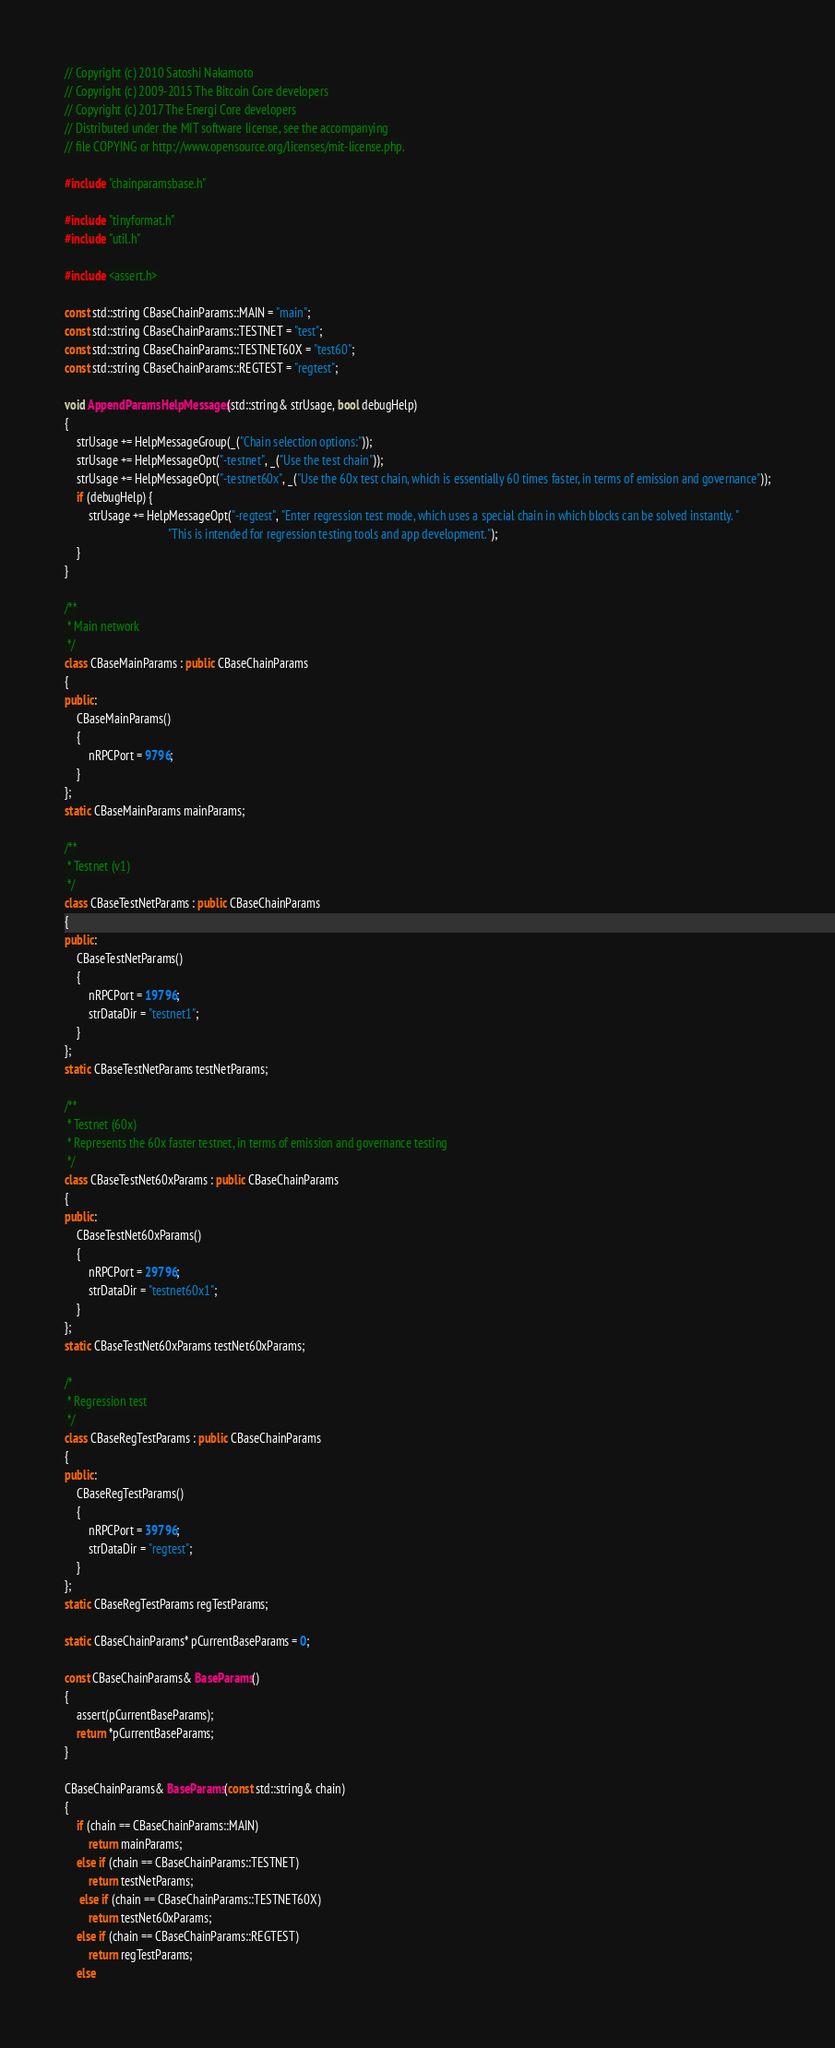<code> <loc_0><loc_0><loc_500><loc_500><_C++_>// Copyright (c) 2010 Satoshi Nakamoto
// Copyright (c) 2009-2015 The Bitcoin Core developers
// Copyright (c) 2017 The Energi Core developers
// Distributed under the MIT software license, see the accompanying
// file COPYING or http://www.opensource.org/licenses/mit-license.php.

#include "chainparamsbase.h"

#include "tinyformat.h"
#include "util.h"

#include <assert.h>

const std::string CBaseChainParams::MAIN = "main";
const std::string CBaseChainParams::TESTNET = "test";
const std::string CBaseChainParams::TESTNET60X = "test60";
const std::string CBaseChainParams::REGTEST = "regtest";

void AppendParamsHelpMessages(std::string& strUsage, bool debugHelp)
{
    strUsage += HelpMessageGroup(_("Chain selection options:"));
    strUsage += HelpMessageOpt("-testnet", _("Use the test chain"));
    strUsage += HelpMessageOpt("-testnet60x", _("Use the 60x test chain, which is essentially 60 times faster, in terms of emission and governance"));
    if (debugHelp) {
        strUsage += HelpMessageOpt("-regtest", "Enter regression test mode, which uses a special chain in which blocks can be solved instantly. "
                                   "This is intended for regression testing tools and app development.");
    }
}

/**
 * Main network
 */
class CBaseMainParams : public CBaseChainParams
{
public:
    CBaseMainParams()
    {
        nRPCPort = 9796;
    }
};
static CBaseMainParams mainParams;

/**
 * Testnet (v1)
 */
class CBaseTestNetParams : public CBaseChainParams
{
public:
    CBaseTestNetParams()
    {
        nRPCPort = 19796;
        strDataDir = "testnet1";
    }
};
static CBaseTestNetParams testNetParams;

/**
 * Testnet (60x)
 * Represents the 60x faster testnet, in terms of emission and governance testing
 */
class CBaseTestNet60xParams : public CBaseChainParams
{
public:
    CBaseTestNet60xParams()
    {
        nRPCPort = 29796;
        strDataDir = "testnet60x1";
    }
};
static CBaseTestNet60xParams testNet60xParams;

/*
 * Regression test
 */
class CBaseRegTestParams : public CBaseChainParams
{
public:
    CBaseRegTestParams()
    {
        nRPCPort = 39796;
        strDataDir = "regtest";
    }
};
static CBaseRegTestParams regTestParams;

static CBaseChainParams* pCurrentBaseParams = 0;

const CBaseChainParams& BaseParams()
{
    assert(pCurrentBaseParams);
    return *pCurrentBaseParams;
}

CBaseChainParams& BaseParams(const std::string& chain)
{
    if (chain == CBaseChainParams::MAIN)
        return mainParams;
    else if (chain == CBaseChainParams::TESTNET)
        return testNetParams;
     else if (chain == CBaseChainParams::TESTNET60X)
        return testNet60xParams;
    else if (chain == CBaseChainParams::REGTEST)
        return regTestParams;
    else</code> 